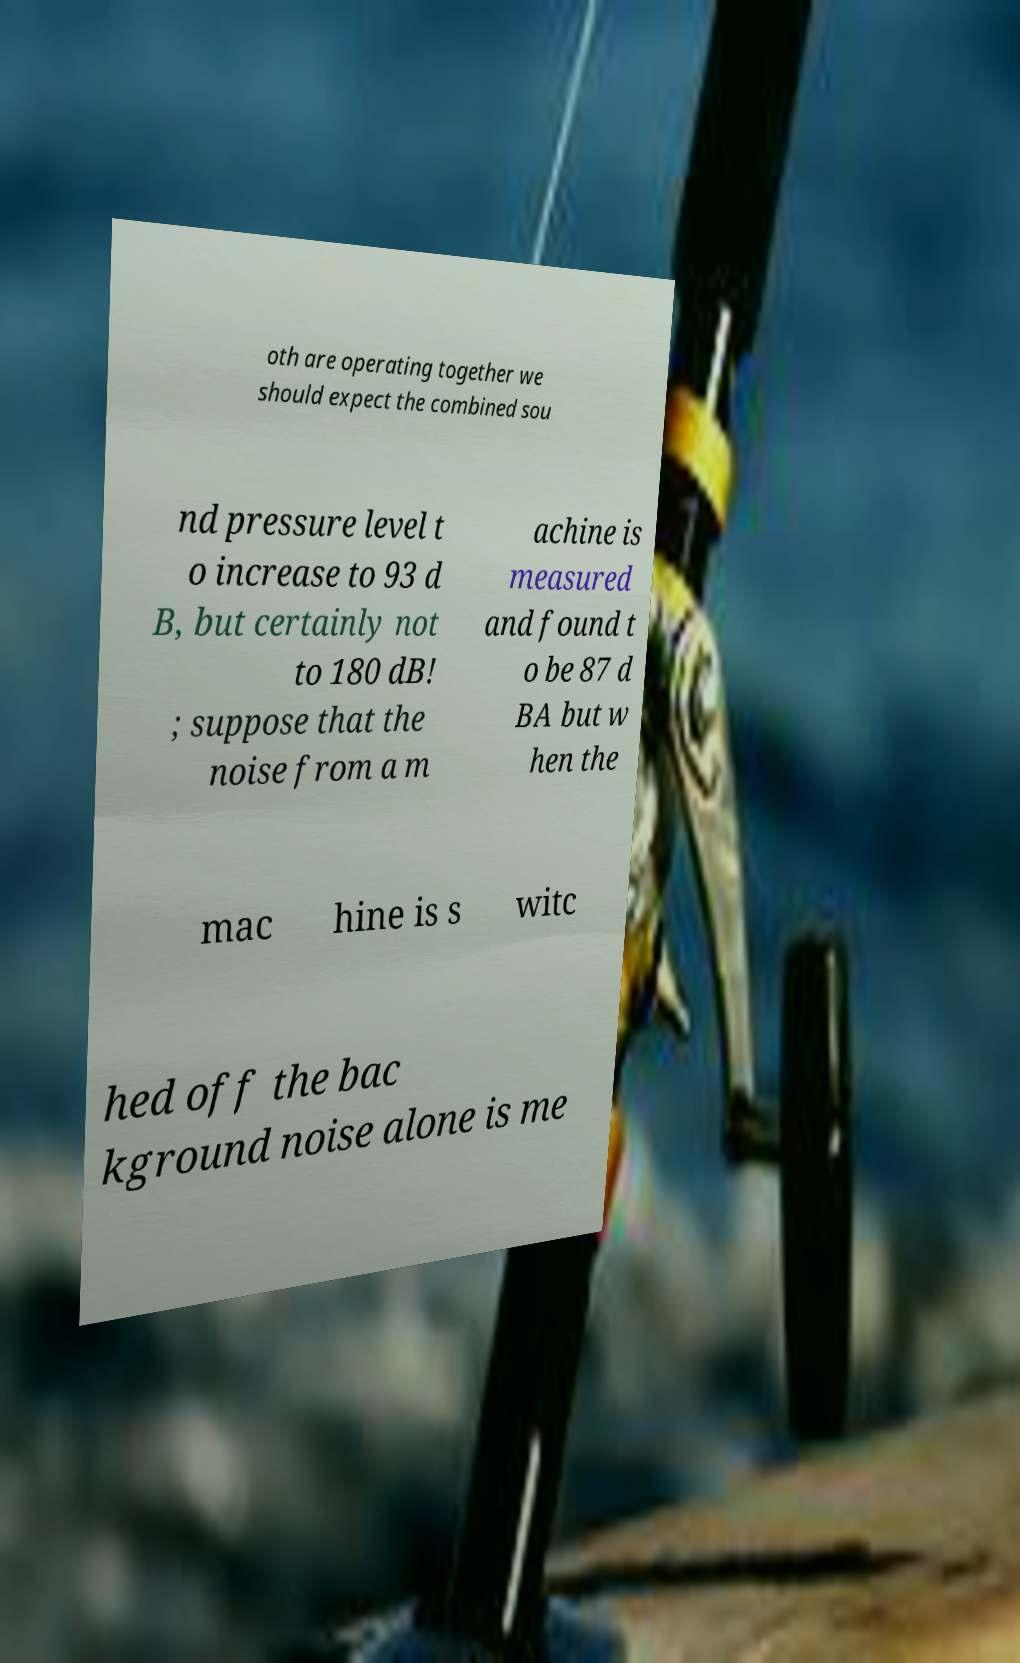Please identify and transcribe the text found in this image. oth are operating together we should expect the combined sou nd pressure level t o increase to 93 d B, but certainly not to 180 dB! ; suppose that the noise from a m achine is measured and found t o be 87 d BA but w hen the mac hine is s witc hed off the bac kground noise alone is me 